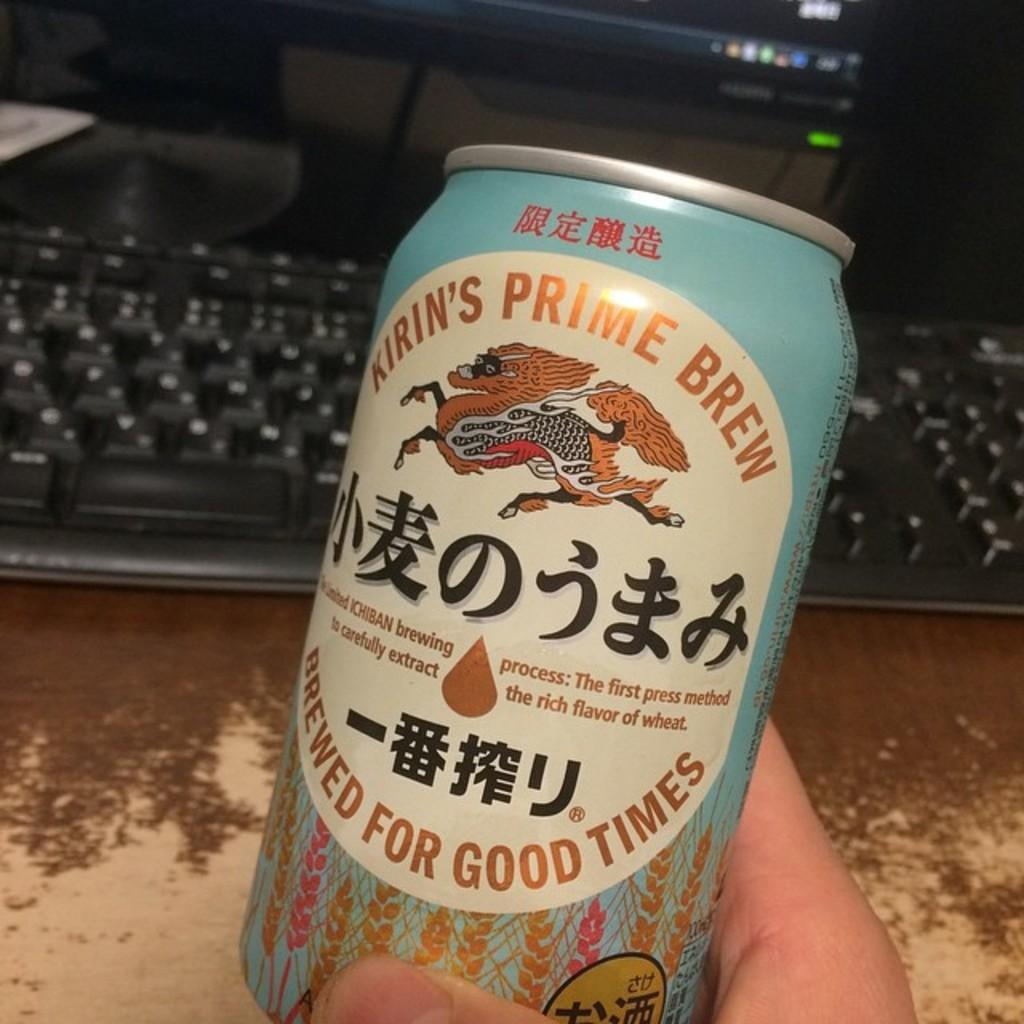Provide a one-sentence caption for the provided image. A person is holding a can of Kirin's Prime Brew. 